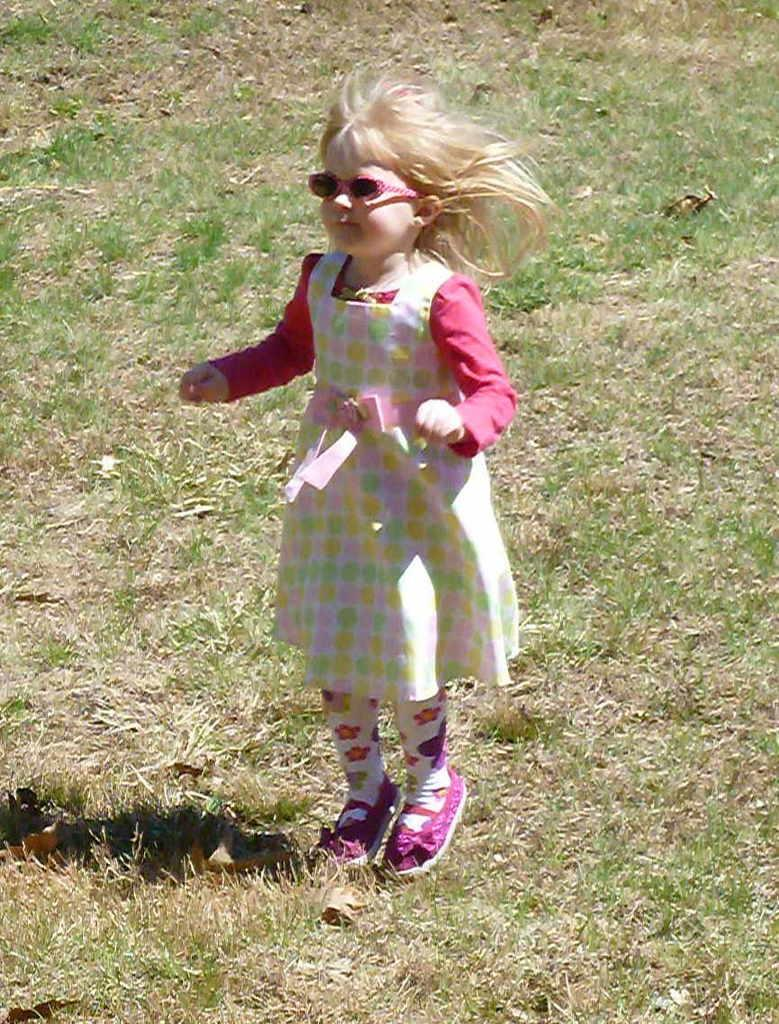Where was the image taken? The image was taken outdoors. What type of surface is visible in the image? There is a ground with grass in the image. What is the girl in the image doing? The girl is jumping on the ground in the image. Can you describe the girl's hair in the image? The girl has short hair. What type of wine is being served at the feast in the image? There is no feast or wine present in the image; it features a girl jumping on a grassy ground outdoors. Are there any cacti visible in the image? There are no cacti present in the image; it features a girl jumping on a grassy ground outdoors. 